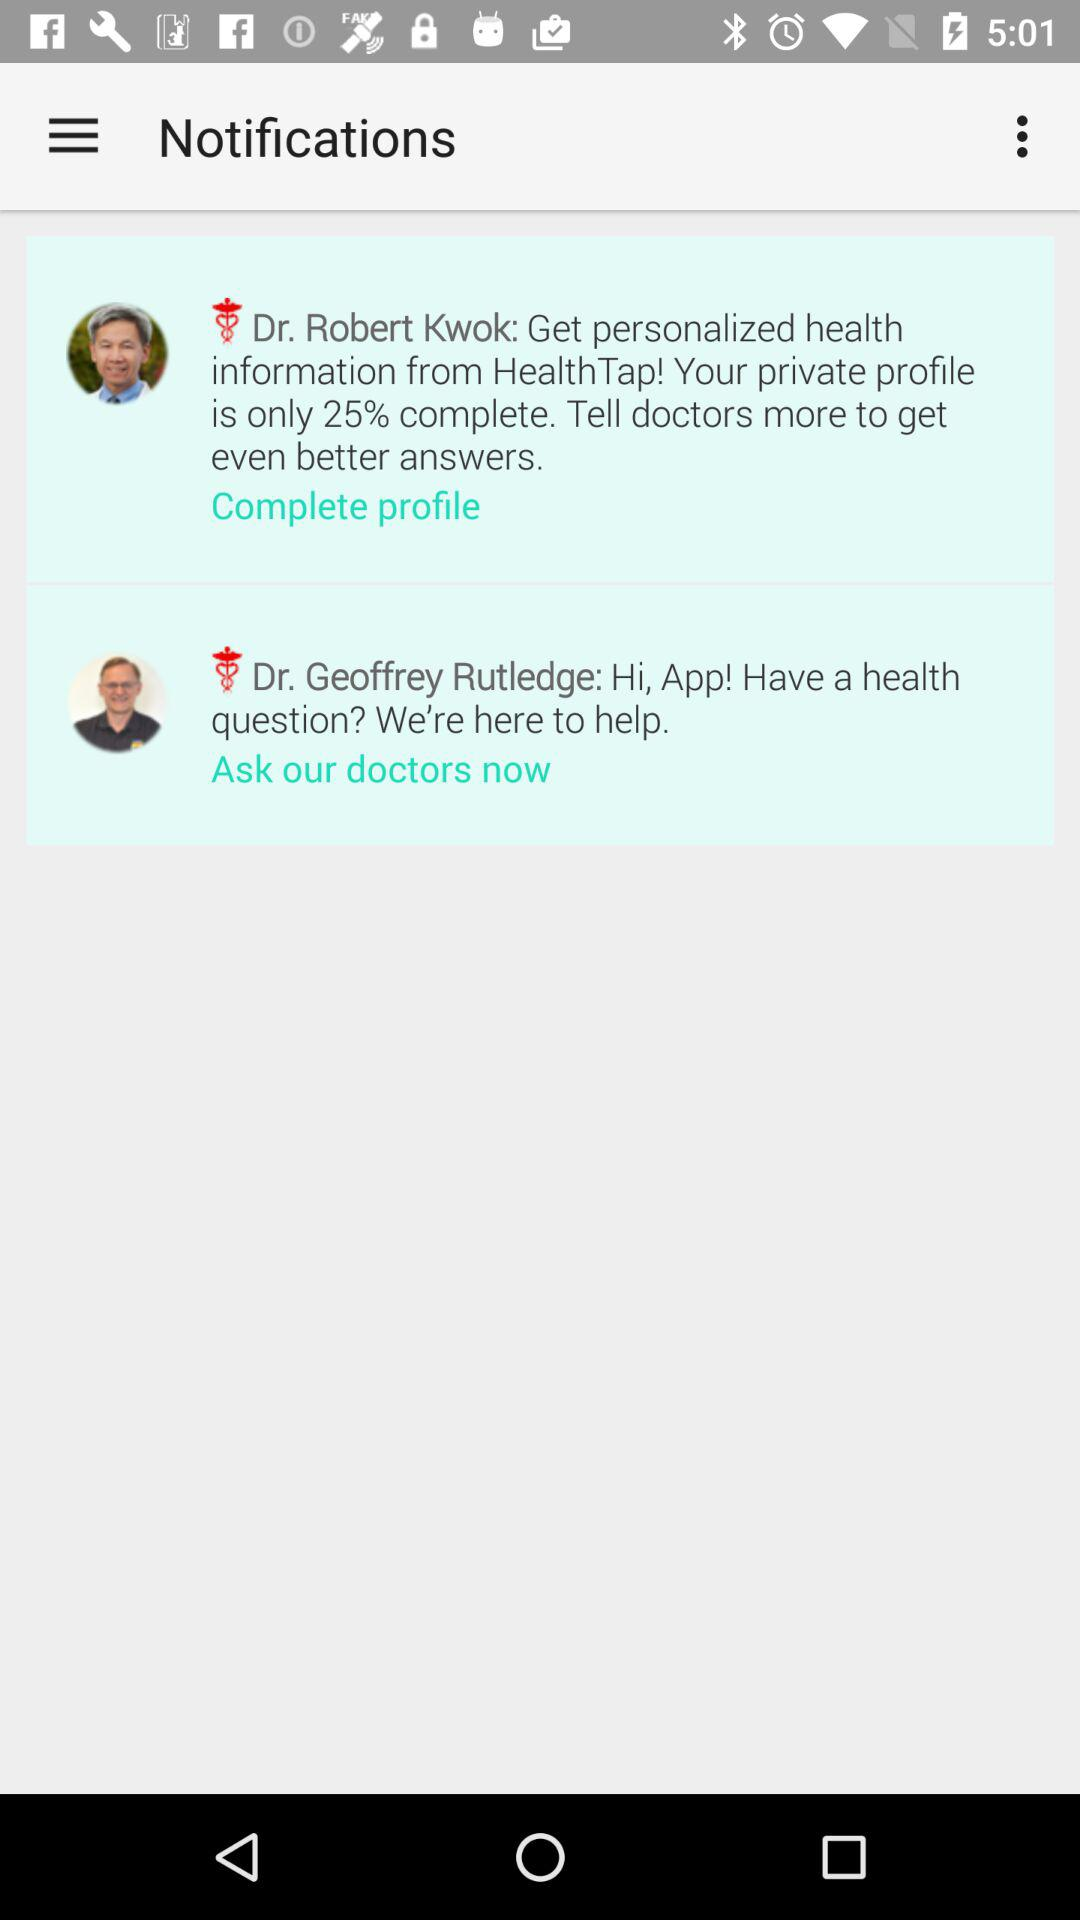Which doctor's notifications are there? The doctors are Dr. Robert Kwok and Dr. Geoffrey Rutledge. 